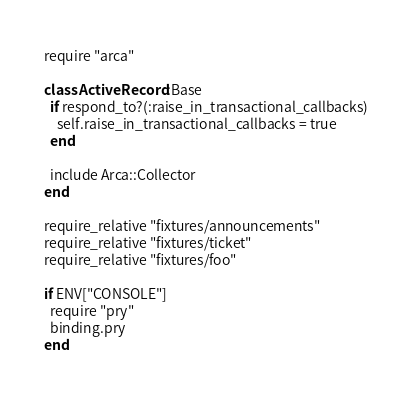<code> <loc_0><loc_0><loc_500><loc_500><_Ruby_>require "arca"

class ActiveRecord::Base
  if respond_to?(:raise_in_transactional_callbacks)
    self.raise_in_transactional_callbacks = true
  end

  include Arca::Collector
end

require_relative "fixtures/announcements"
require_relative "fixtures/ticket"
require_relative "fixtures/foo"

if ENV["CONSOLE"]
  require "pry"
  binding.pry
end
</code> 